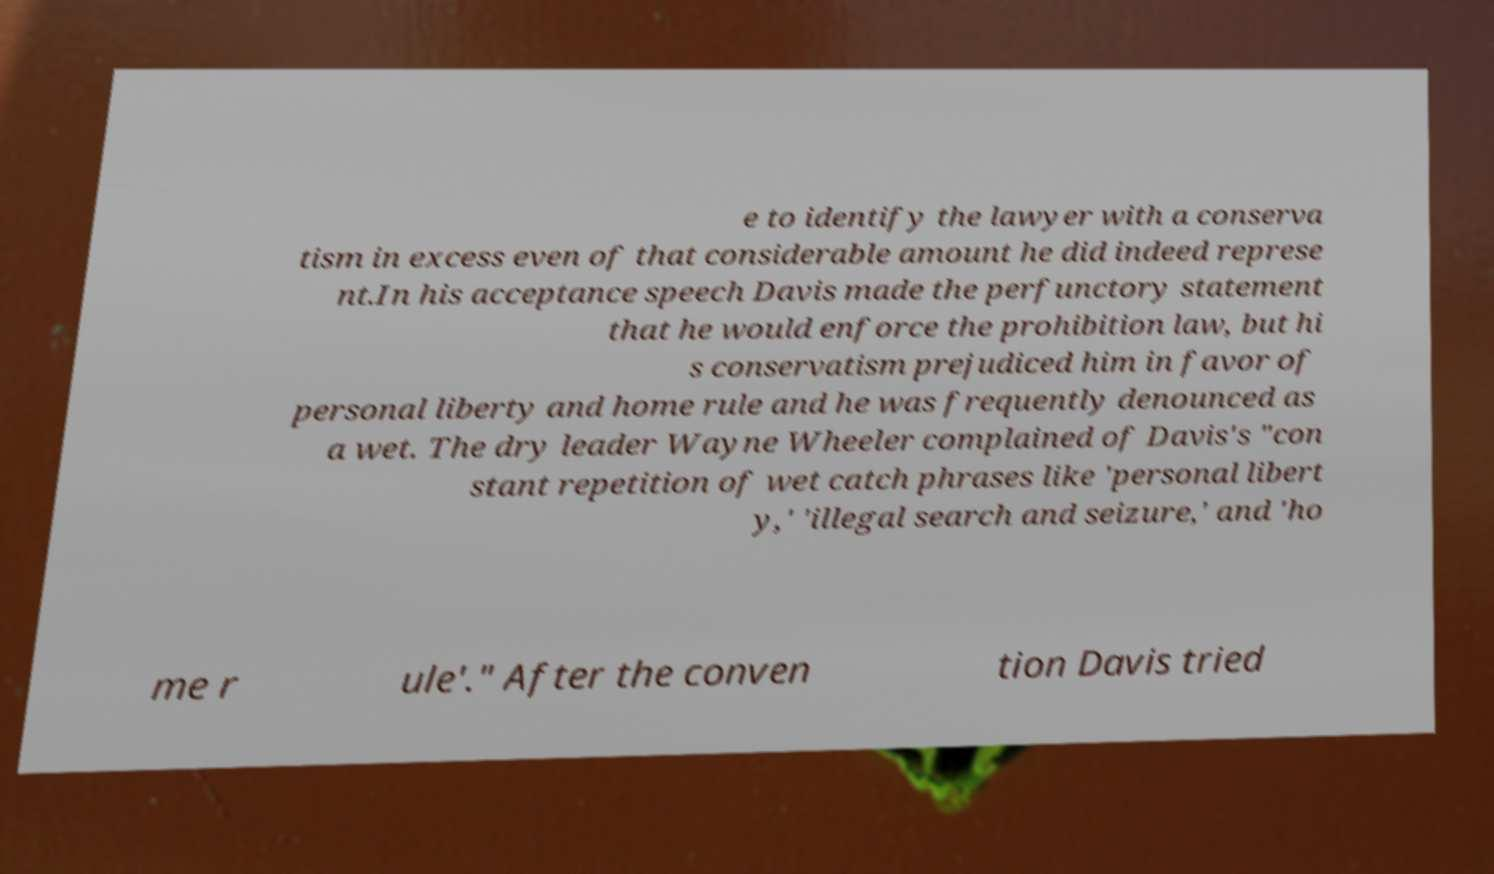For documentation purposes, I need the text within this image transcribed. Could you provide that? e to identify the lawyer with a conserva tism in excess even of that considerable amount he did indeed represe nt.In his acceptance speech Davis made the perfunctory statement that he would enforce the prohibition law, but hi s conservatism prejudiced him in favor of personal liberty and home rule and he was frequently denounced as a wet. The dry leader Wayne Wheeler complained of Davis's "con stant repetition of wet catch phrases like 'personal libert y,' 'illegal search and seizure,' and 'ho me r ule'." After the conven tion Davis tried 